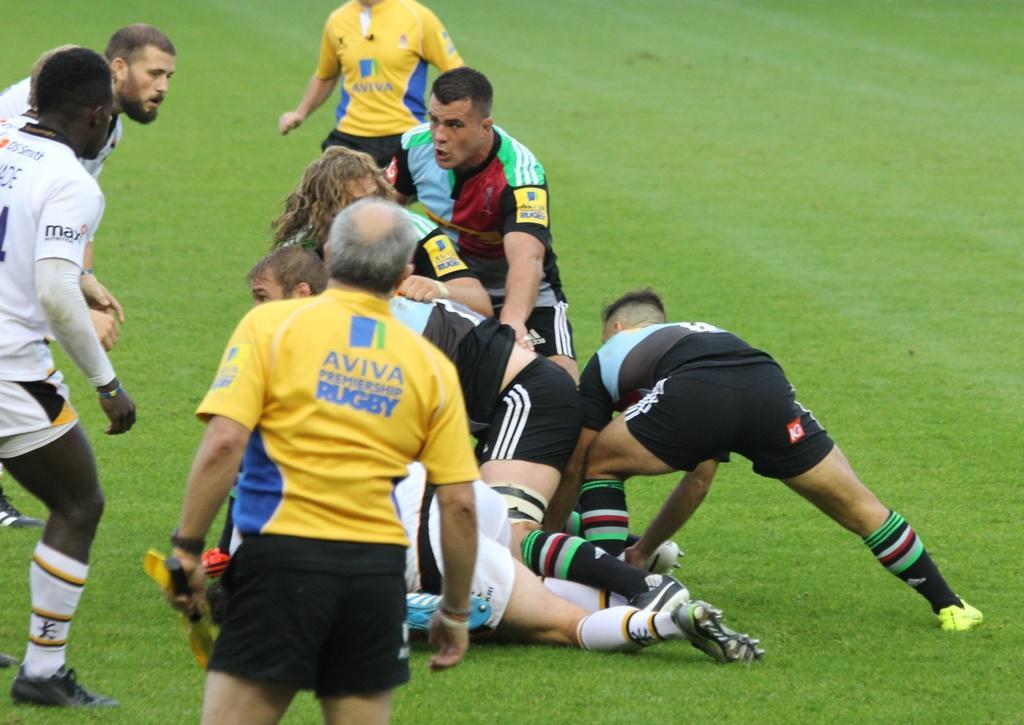Please provide a concise description of this image. This image is taken outdoors. At the bottom of the image there is a ground with grass on it. On the left side of the image there are two men standing on the ground. In the middle of the image a man is standing and a few men are playing on the ground. 